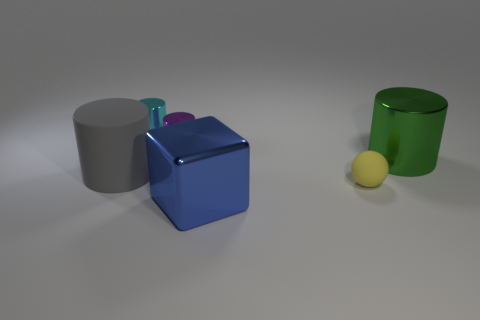What materials do the objects in the image appear to be made of? The objects in the image appear to have different materials. The blue block and the purple cylinder have a metallic sheen, indicative of metal. The grey cylinder appears matte, possibly made of stone or ceramic, whereas the green cylinder looks like it could be made of glass or plastic due to its transparency. Lastly, the small yellow ball seems to have a rubbery texture. 